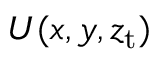<formula> <loc_0><loc_0><loc_500><loc_500>U ( x , y , z _ { t } )</formula> 